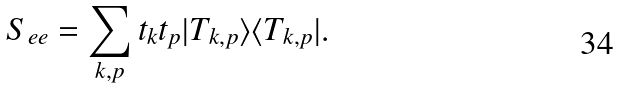Convert formula to latex. <formula><loc_0><loc_0><loc_500><loc_500>S _ { e e } = \sum _ { k , p } t _ { k } t _ { p } | T _ { k , p } \rangle \langle T _ { k , p } | .</formula> 